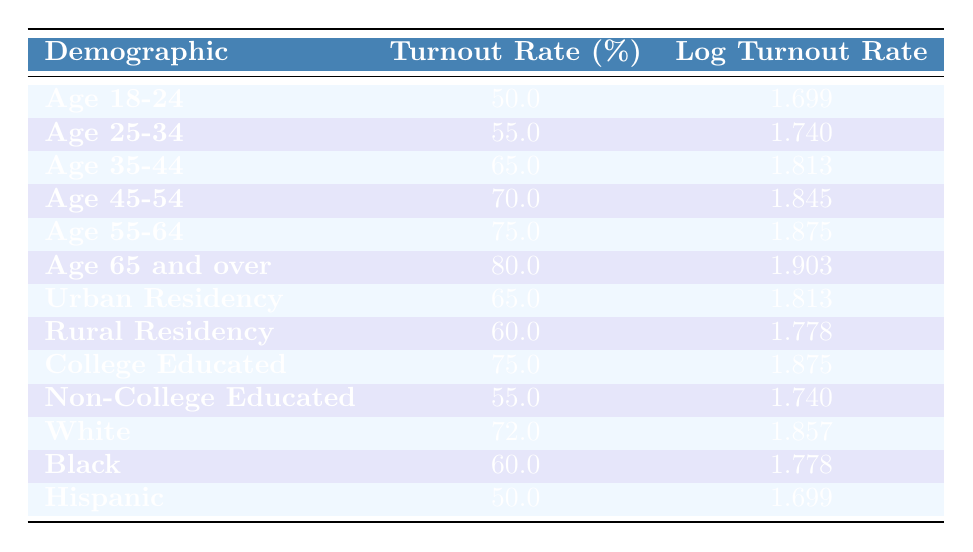What is the voter turnout rate for the demographic "Age 18-24"? The table shows that the demographic "Age 18-24" has a turnout rate listed in the corresponding row, which is 50.0%.
Answer: 50.0 Which demographic group has the highest turnout rate? By examining the turnout rates in the table, the highest value is in the "Age 65 and over" demographic, which has a turnout rate of 80.0%.
Answer: Age 65 and over What is the difference in voter turnout rates between "Age 35-44" and "Age 55-64"? The turnout rate for "Age 35-44" is 65.0% and for "Age 55-64" it is 75.0%. Calculating the difference: 75.0% - 65.0% = 10.0%.
Answer: 10.0 Is the voter turnout rate for "Black" demographics higher than for "Hispanic"? The turnout rate for "Black" is 60.0% while for "Hispanic" it is 50.0%. Since 60.0% > 50.0%, the statement is true.
Answer: Yes What is the average voter turnout rate for the two residency categories: Urban and Rural? The Urban residency turnout rate is 65.0% and Rural is 60.0%. To find the average: (65.0% + 60.0%)/2 = 62.5%.
Answer: 62.5 